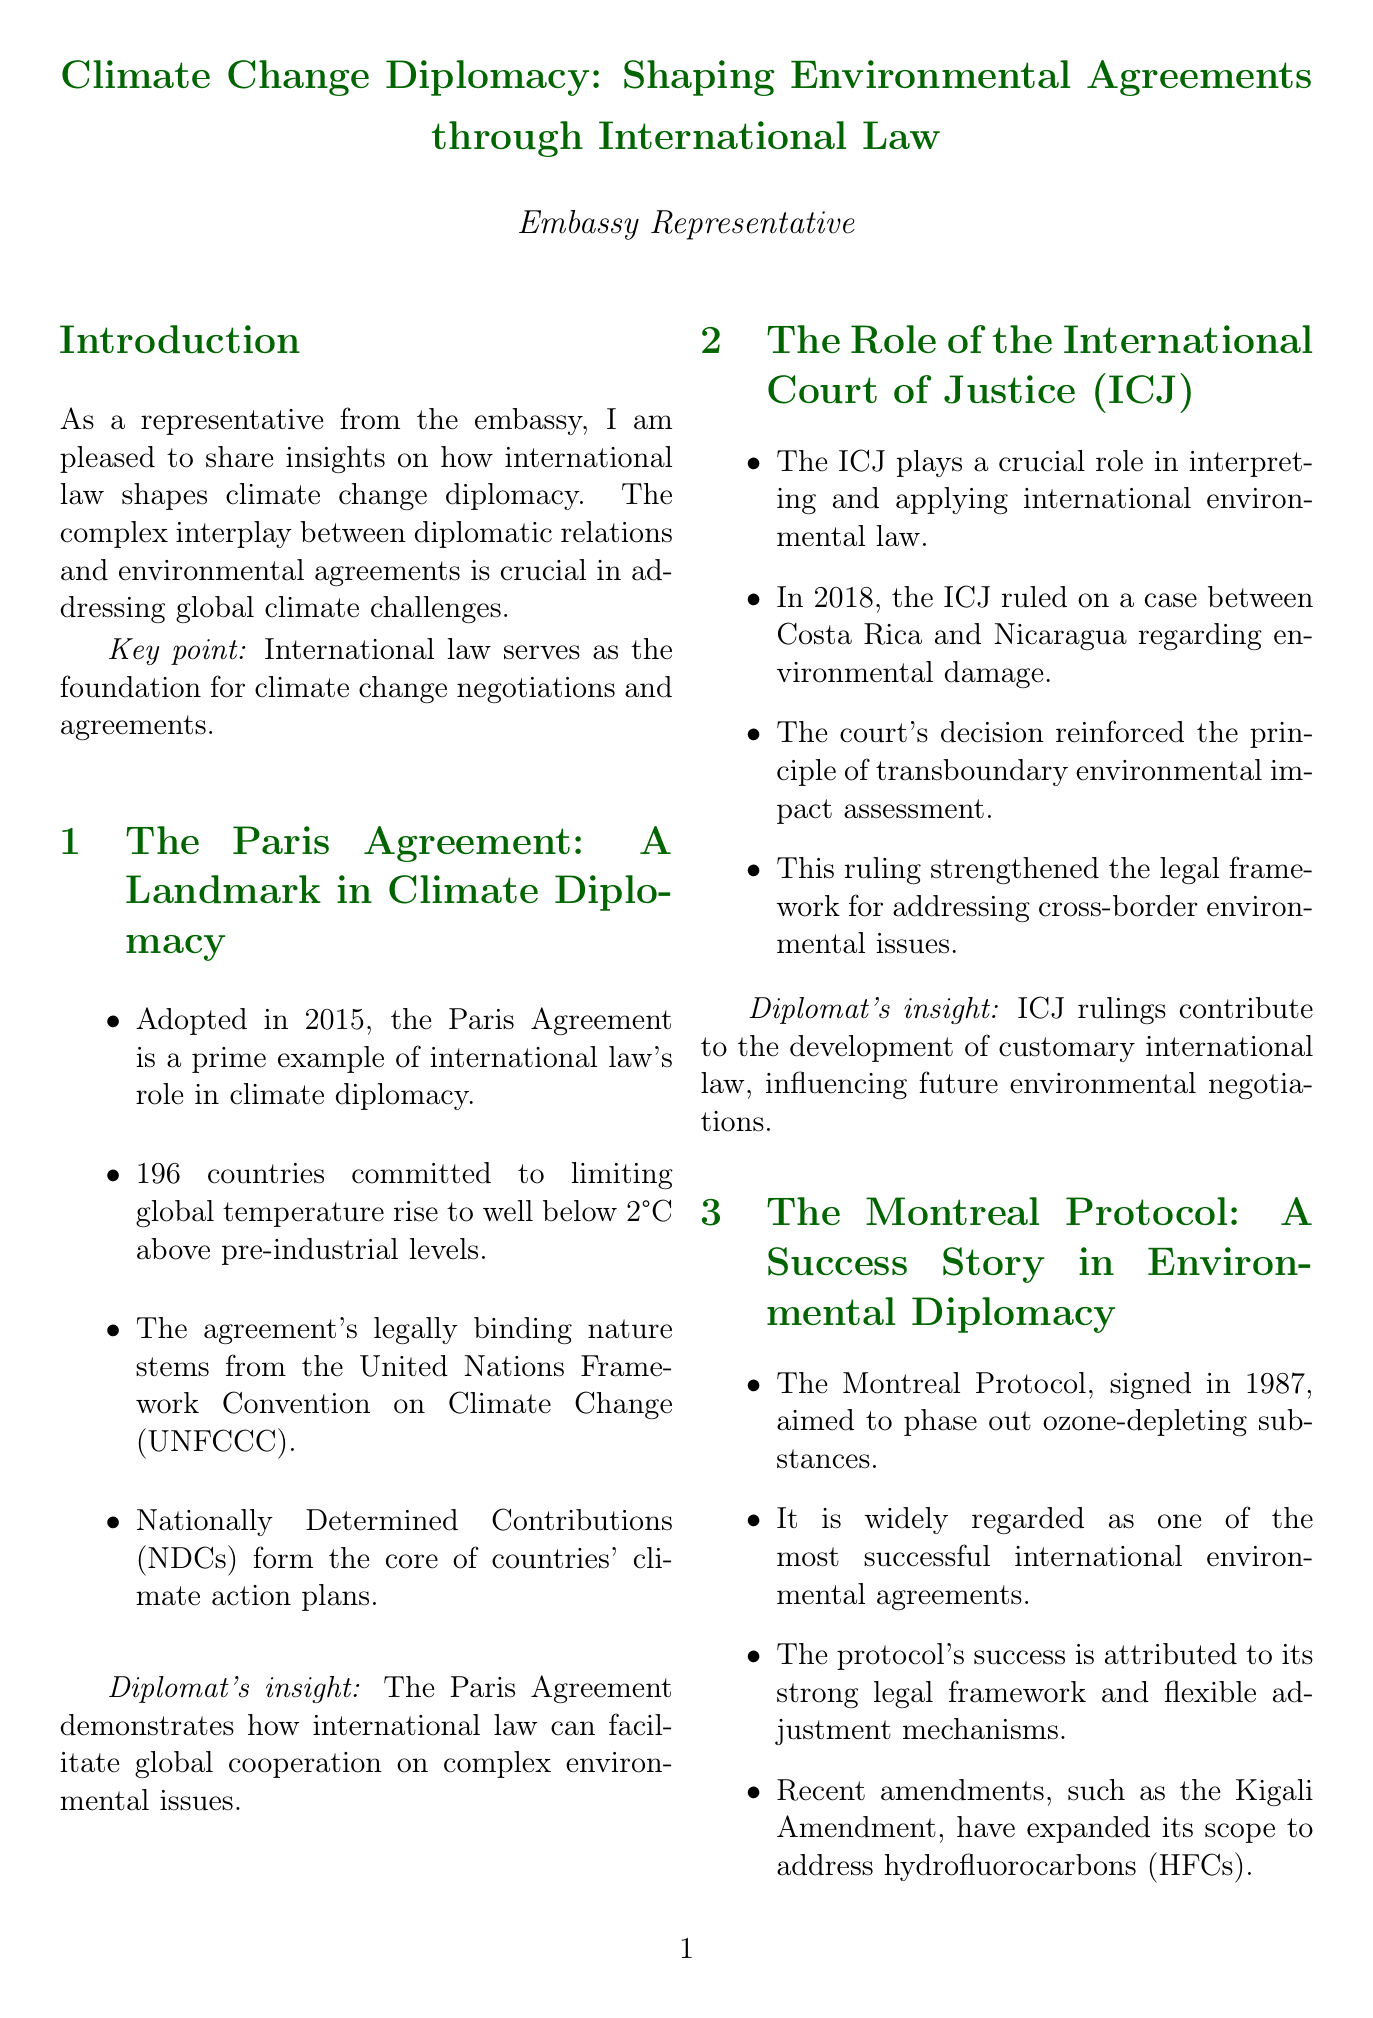What year was the Paris Agreement adopted? The document states that the Paris Agreement was adopted in 2015.
Answer: 2015 How many countries committed to the Paris Agreement? The document mentions that 196 countries committed to the Paris Agreement.
Answer: 196 What is the purpose of the Montreal Protocol? The document describes the purpose of the Montreal Protocol as phasing out ozone-depleting substances.
Answer: Phase out ozone-depleting substances What principle complicates national interest negotiations? The document discusses the principle of common but differentiated responsibilities as complicating negotiations.
Answer: Common but differentiated responsibilities In what year did the ICJ rule on the case between Costa Rica and Nicaragua? The document specifies that the ICJ ruled on the case between Costa Rica and Nicaragua in 2018.
Answer: 2018 What significant amendment was recently added to the Montreal Protocol? The document refers to the Kigali Amendment as a recent amendment to the Montreal Protocol.
Answer: Kigali Amendment What emerging concept is influencing international environmental law? The document indicates that the concept of climate justice is influencing international environmental law.
Answer: Climate justice What role does the United Nations Environment Programme play according to the document? The document explains that the UNEP is working on strengthening environmental rule of law.
Answer: Strengthening environmental rule of law 